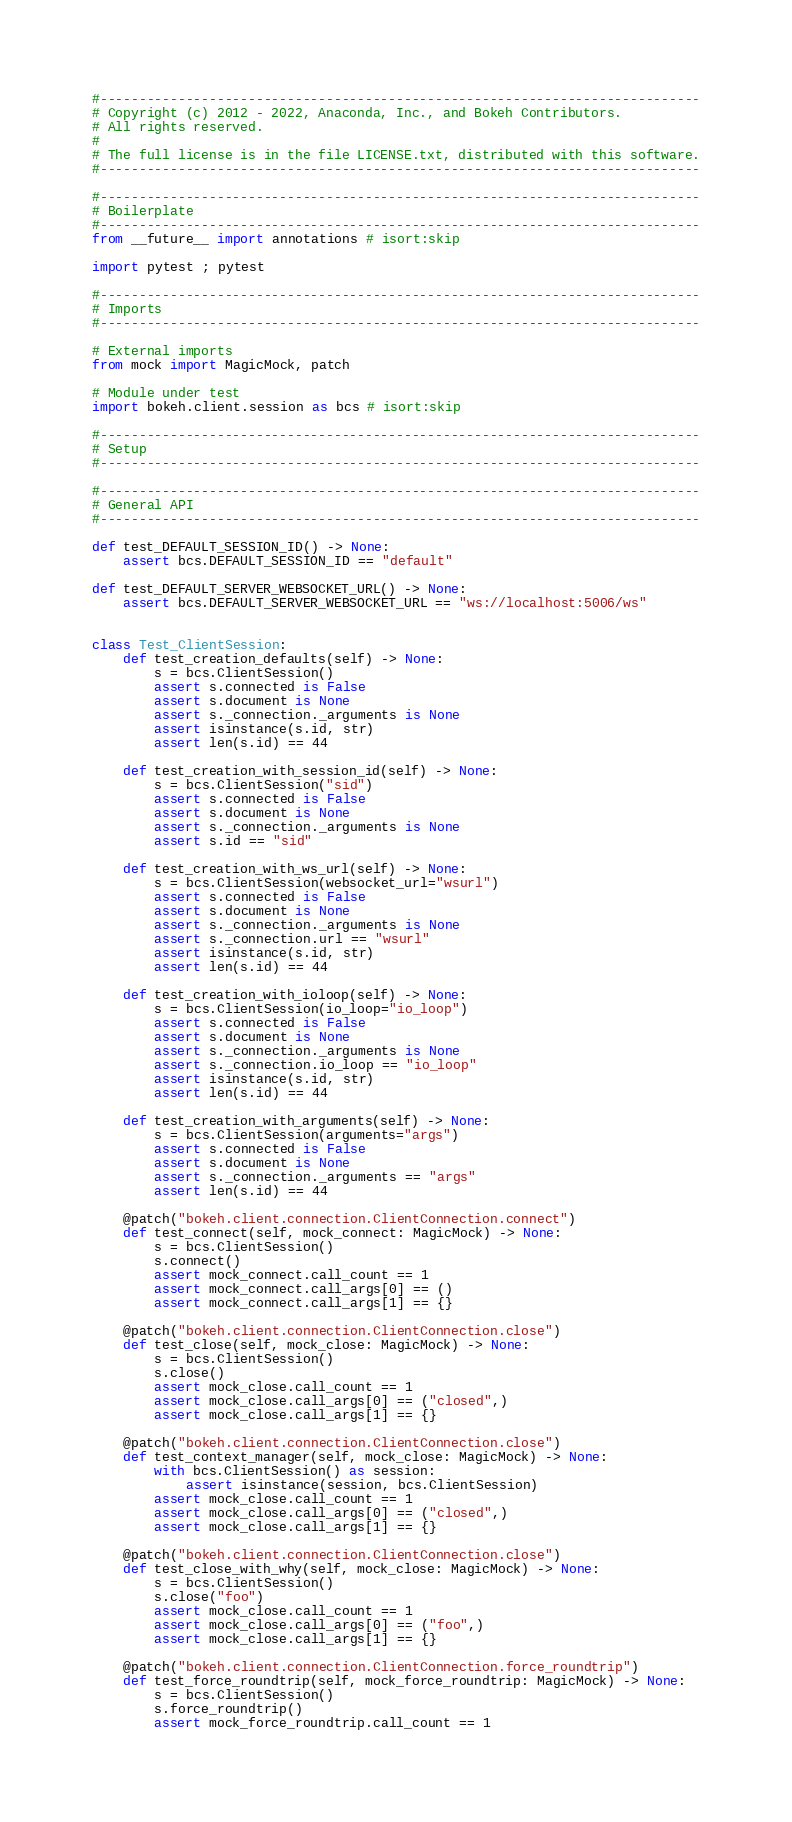<code> <loc_0><loc_0><loc_500><loc_500><_Python_>#-----------------------------------------------------------------------------
# Copyright (c) 2012 - 2022, Anaconda, Inc., and Bokeh Contributors.
# All rights reserved.
#
# The full license is in the file LICENSE.txt, distributed with this software.
#-----------------------------------------------------------------------------

#-----------------------------------------------------------------------------
# Boilerplate
#-----------------------------------------------------------------------------
from __future__ import annotations # isort:skip

import pytest ; pytest

#-----------------------------------------------------------------------------
# Imports
#-----------------------------------------------------------------------------

# External imports
from mock import MagicMock, patch

# Module under test
import bokeh.client.session as bcs # isort:skip

#-----------------------------------------------------------------------------
# Setup
#-----------------------------------------------------------------------------

#-----------------------------------------------------------------------------
# General API
#-----------------------------------------------------------------------------

def test_DEFAULT_SESSION_ID() -> None:
    assert bcs.DEFAULT_SESSION_ID == "default"

def test_DEFAULT_SERVER_WEBSOCKET_URL() -> None:
    assert bcs.DEFAULT_SERVER_WEBSOCKET_URL == "ws://localhost:5006/ws"


class Test_ClientSession:
    def test_creation_defaults(self) -> None:
        s = bcs.ClientSession()
        assert s.connected is False
        assert s.document is None
        assert s._connection._arguments is None
        assert isinstance(s.id, str)
        assert len(s.id) == 44

    def test_creation_with_session_id(self) -> None:
        s = bcs.ClientSession("sid")
        assert s.connected is False
        assert s.document is None
        assert s._connection._arguments is None
        assert s.id == "sid"

    def test_creation_with_ws_url(self) -> None:
        s = bcs.ClientSession(websocket_url="wsurl")
        assert s.connected is False
        assert s.document is None
        assert s._connection._arguments is None
        assert s._connection.url == "wsurl"
        assert isinstance(s.id, str)
        assert len(s.id) == 44

    def test_creation_with_ioloop(self) -> None:
        s = bcs.ClientSession(io_loop="io_loop")
        assert s.connected is False
        assert s.document is None
        assert s._connection._arguments is None
        assert s._connection.io_loop == "io_loop"
        assert isinstance(s.id, str)
        assert len(s.id) == 44

    def test_creation_with_arguments(self) -> None:
        s = bcs.ClientSession(arguments="args")
        assert s.connected is False
        assert s.document is None
        assert s._connection._arguments == "args"
        assert len(s.id) == 44

    @patch("bokeh.client.connection.ClientConnection.connect")
    def test_connect(self, mock_connect: MagicMock) -> None:
        s = bcs.ClientSession()
        s.connect()
        assert mock_connect.call_count == 1
        assert mock_connect.call_args[0] == ()
        assert mock_connect.call_args[1] == {}

    @patch("bokeh.client.connection.ClientConnection.close")
    def test_close(self, mock_close: MagicMock) -> None:
        s = bcs.ClientSession()
        s.close()
        assert mock_close.call_count == 1
        assert mock_close.call_args[0] == ("closed",)
        assert mock_close.call_args[1] == {}

    @patch("bokeh.client.connection.ClientConnection.close")
    def test_context_manager(self, mock_close: MagicMock) -> None:
        with bcs.ClientSession() as session:
            assert isinstance(session, bcs.ClientSession)
        assert mock_close.call_count == 1
        assert mock_close.call_args[0] == ("closed",)
        assert mock_close.call_args[1] == {}

    @patch("bokeh.client.connection.ClientConnection.close")
    def test_close_with_why(self, mock_close: MagicMock) -> None:
        s = bcs.ClientSession()
        s.close("foo")
        assert mock_close.call_count == 1
        assert mock_close.call_args[0] == ("foo",)
        assert mock_close.call_args[1] == {}

    @patch("bokeh.client.connection.ClientConnection.force_roundtrip")
    def test_force_roundtrip(self, mock_force_roundtrip: MagicMock) -> None:
        s = bcs.ClientSession()
        s.force_roundtrip()
        assert mock_force_roundtrip.call_count == 1</code> 